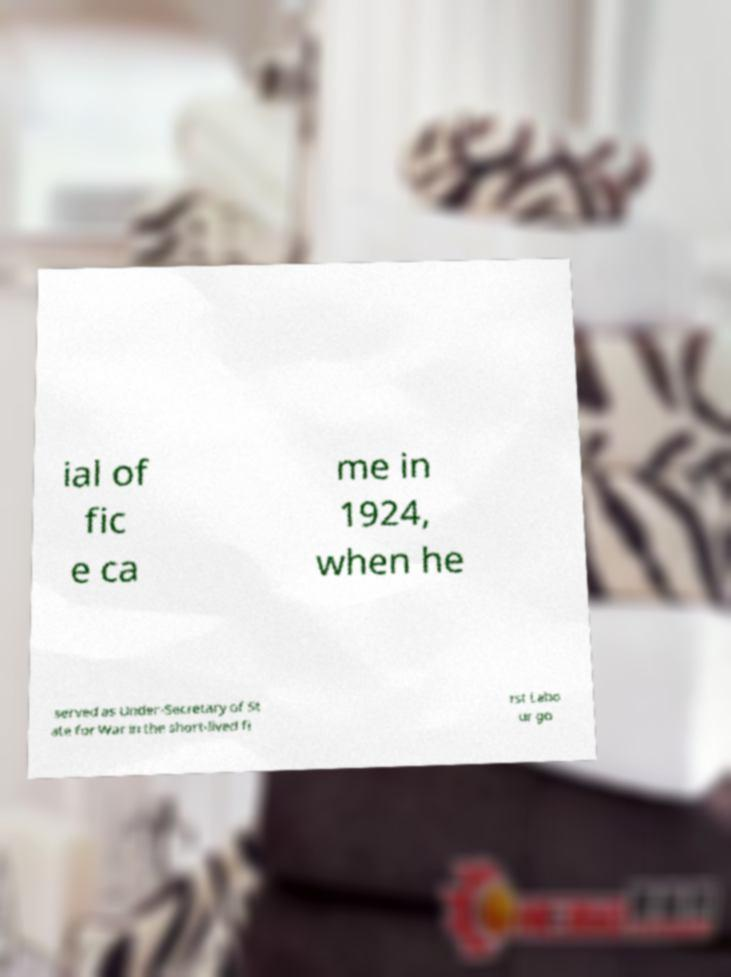Can you read and provide the text displayed in the image?This photo seems to have some interesting text. Can you extract and type it out for me? ial of fic e ca me in 1924, when he served as Under-Secretary of St ate for War in the short-lived fi rst Labo ur go 